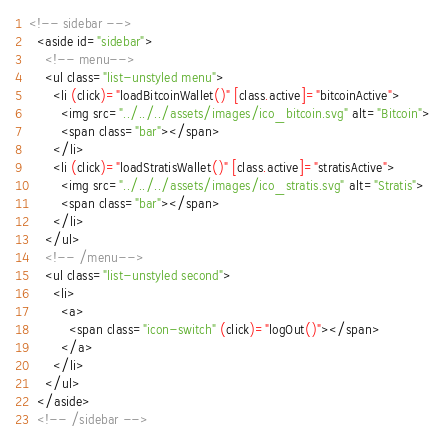<code> <loc_0><loc_0><loc_500><loc_500><_HTML_><!-- sidebar -->
  <aside id="sidebar">
    <!-- menu-->
    <ul class="list-unstyled menu">
      <li (click)="loadBitcoinWallet()" [class.active]="bitcoinActive">
        <img src="../../../assets/images/ico_bitcoin.svg" alt="Bitcoin">
        <span class="bar"></span>
      </li>
      <li (click)="loadStratisWallet()" [class.active]="stratisActive">
        <img src="../../../assets/images/ico_stratis.svg" alt="Stratis">
        <span class="bar"></span>
      </li>
    </ul>
    <!-- /menu-->
    <ul class="list-unstyled second">
      <li>
        <a>
          <span class="icon-switch" (click)="logOut()"></span>
        </a>
      </li>
    </ul>
  </aside>
  <!-- /sidebar -->
</code> 